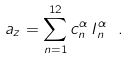Convert formula to latex. <formula><loc_0><loc_0><loc_500><loc_500>a _ { z } = \sum _ { n = 1 } ^ { 1 2 } c ^ { \alpha } _ { n } \, I ^ { \alpha } _ { n } \ .</formula> 